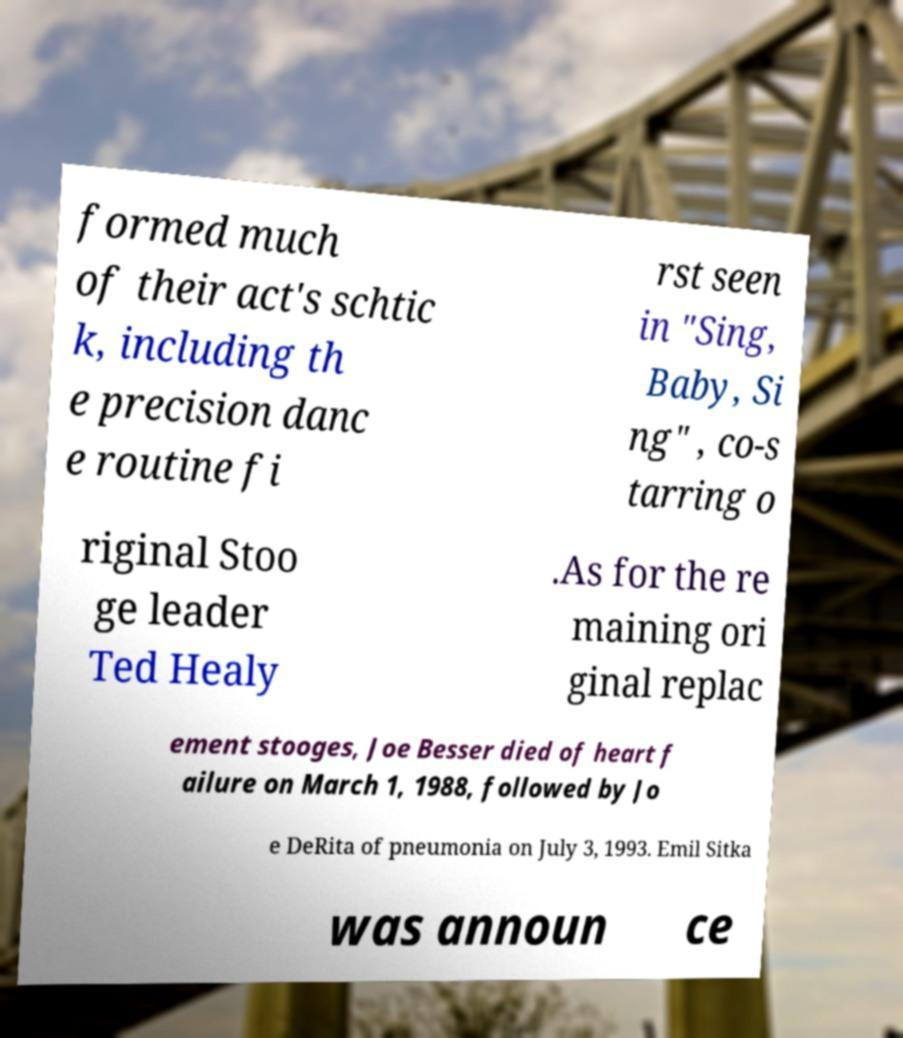I need the written content from this picture converted into text. Can you do that? formed much of their act's schtic k, including th e precision danc e routine fi rst seen in "Sing, Baby, Si ng" , co-s tarring o riginal Stoo ge leader Ted Healy .As for the re maining ori ginal replac ement stooges, Joe Besser died of heart f ailure on March 1, 1988, followed by Jo e DeRita of pneumonia on July 3, 1993. Emil Sitka was announ ce 